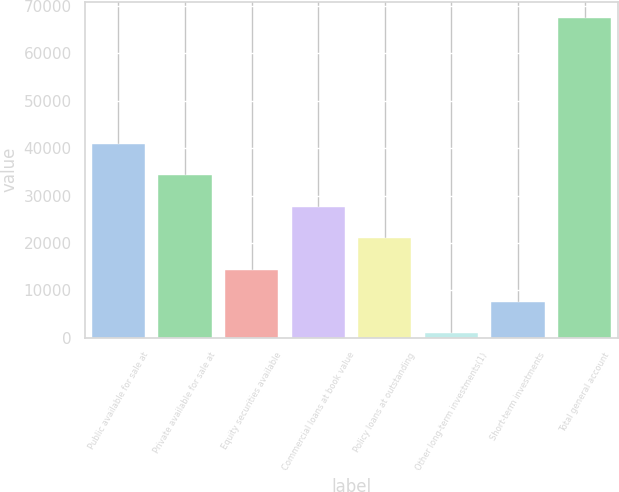Convert chart. <chart><loc_0><loc_0><loc_500><loc_500><bar_chart><fcel>Public available for sale at<fcel>Private available for sale at<fcel>Equity securities available<fcel>Commercial loans at book value<fcel>Policy loans at outstanding<fcel>Other long-term investments(1)<fcel>Short-term investments<fcel>Total general account<nl><fcel>40886.8<fcel>34234.5<fcel>14277.6<fcel>27582.2<fcel>20929.9<fcel>973<fcel>7625.3<fcel>67496<nl></chart> 